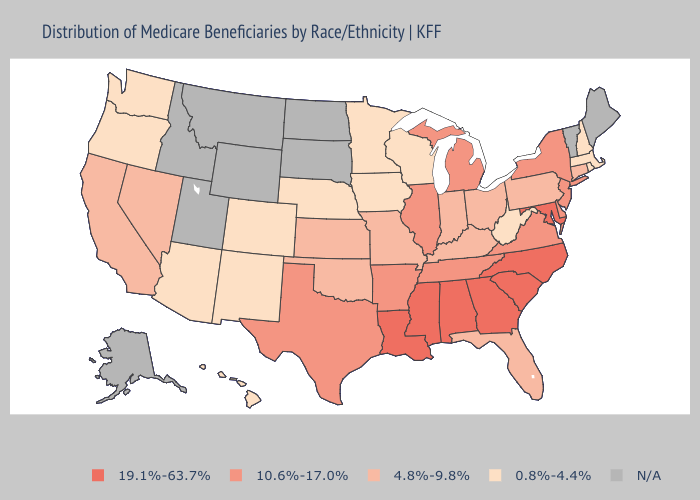Which states have the highest value in the USA?
Quick response, please. Alabama, Georgia, Louisiana, Maryland, Mississippi, North Carolina, South Carolina. Does Delaware have the highest value in the South?
Keep it brief. No. Name the states that have a value in the range 19.1%-63.7%?
Write a very short answer. Alabama, Georgia, Louisiana, Maryland, Mississippi, North Carolina, South Carolina. What is the value of Wyoming?
Be succinct. N/A. Does Kentucky have the lowest value in the South?
Short answer required. No. Among the states that border Mississippi , does Arkansas have the lowest value?
Concise answer only. Yes. Name the states that have a value in the range 0.8%-4.4%?
Give a very brief answer. Arizona, Colorado, Hawaii, Iowa, Massachusetts, Minnesota, Nebraska, New Hampshire, New Mexico, Oregon, Rhode Island, Washington, West Virginia, Wisconsin. What is the highest value in the USA?
Answer briefly. 19.1%-63.7%. Name the states that have a value in the range 4.8%-9.8%?
Give a very brief answer. California, Connecticut, Florida, Indiana, Kansas, Kentucky, Missouri, Nevada, Ohio, Oklahoma, Pennsylvania. Which states have the highest value in the USA?
Answer briefly. Alabama, Georgia, Louisiana, Maryland, Mississippi, North Carolina, South Carolina. Among the states that border Texas , does New Mexico have the lowest value?
Write a very short answer. Yes. What is the highest value in the USA?
Short answer required. 19.1%-63.7%. Name the states that have a value in the range N/A?
Quick response, please. Alaska, Idaho, Maine, Montana, North Dakota, South Dakota, Utah, Vermont, Wyoming. Name the states that have a value in the range N/A?
Write a very short answer. Alaska, Idaho, Maine, Montana, North Dakota, South Dakota, Utah, Vermont, Wyoming. Which states hav the highest value in the MidWest?
Quick response, please. Illinois, Michigan. 